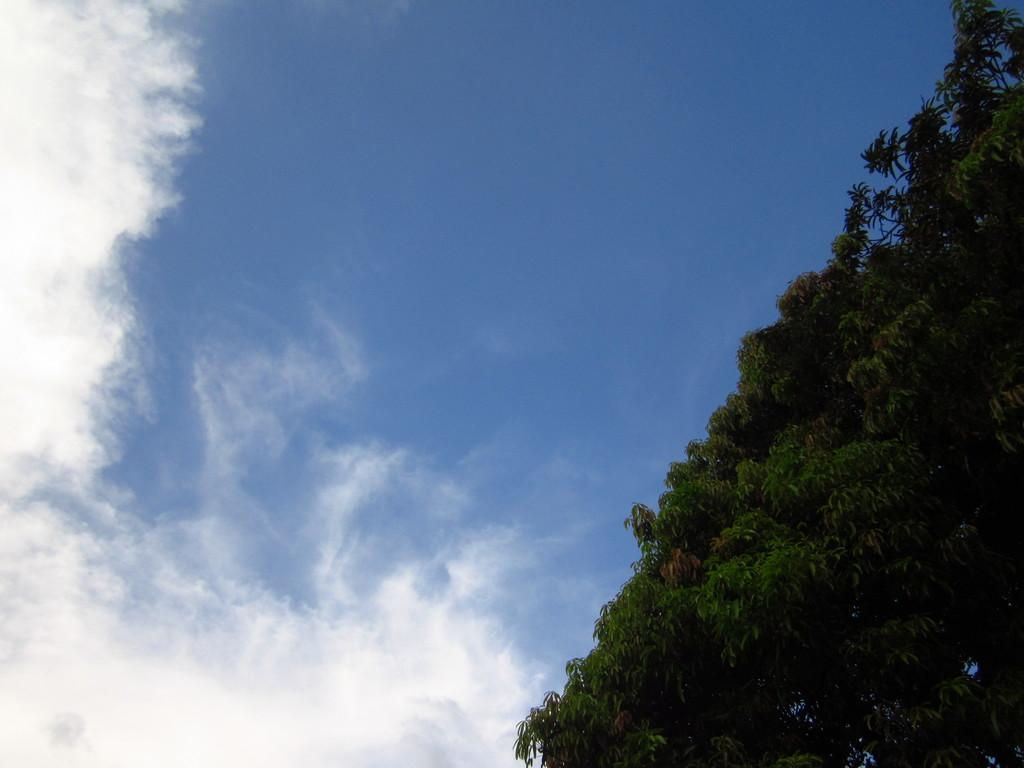What type of vegetation can be seen in the image? There are trees in the image. What is visible in the background of the image? The sky is visible in the background of the image. What can be observed in the sky? Clouds are present in the sky. What type of marble is visible on the ground in the image? There is no marble present in the image; it features trees and a sky with clouds. 